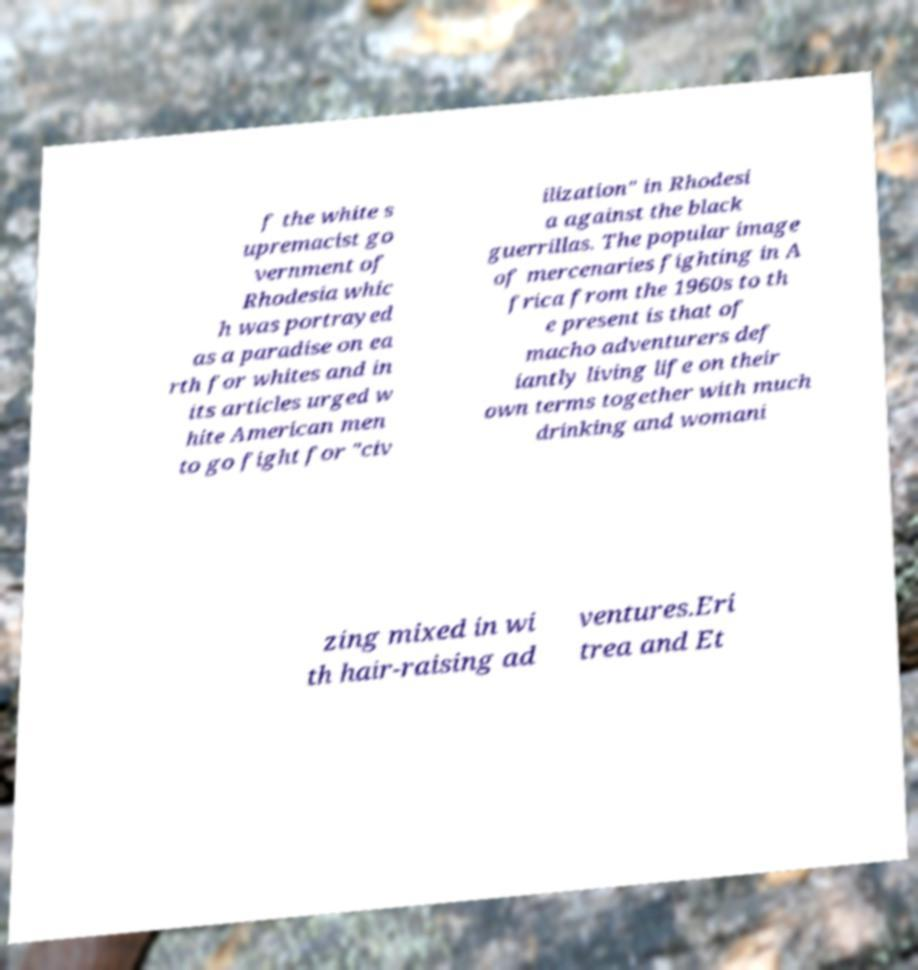What messages or text are displayed in this image? I need them in a readable, typed format. f the white s upremacist go vernment of Rhodesia whic h was portrayed as a paradise on ea rth for whites and in its articles urged w hite American men to go fight for "civ ilization" in Rhodesi a against the black guerrillas. The popular image of mercenaries fighting in A frica from the 1960s to th e present is that of macho adventurers def iantly living life on their own terms together with much drinking and womani zing mixed in wi th hair-raising ad ventures.Eri trea and Et 